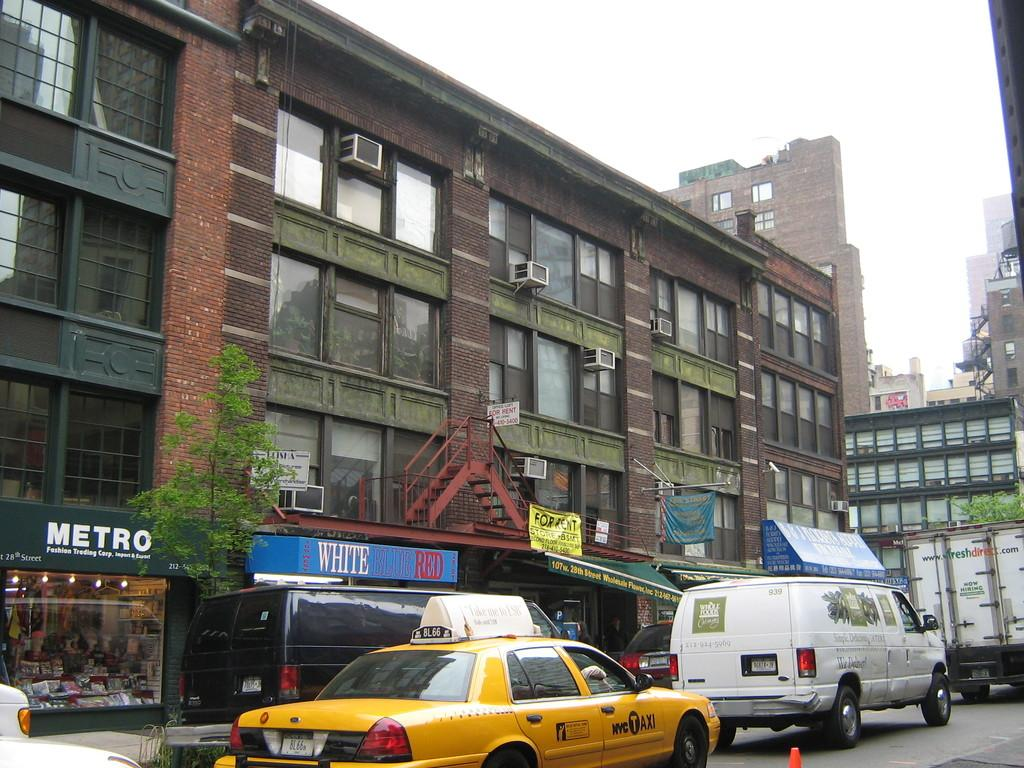<image>
Write a terse but informative summary of the picture. A yellow and black taxo parks outside a building that says Metro on it. 